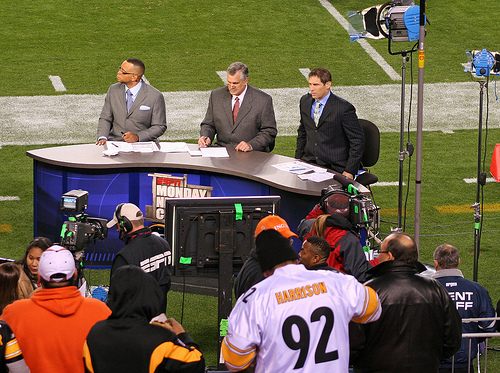<image>
Is there a man behind the fence? Yes. From this viewpoint, the man is positioned behind the fence, with the fence partially or fully occluding the man. Is there a man behind the desk? Yes. From this viewpoint, the man is positioned behind the desk, with the desk partially or fully occluding the man. Is there a announcer behind the field? No. The announcer is not behind the field. From this viewpoint, the announcer appears to be positioned elsewhere in the scene. 